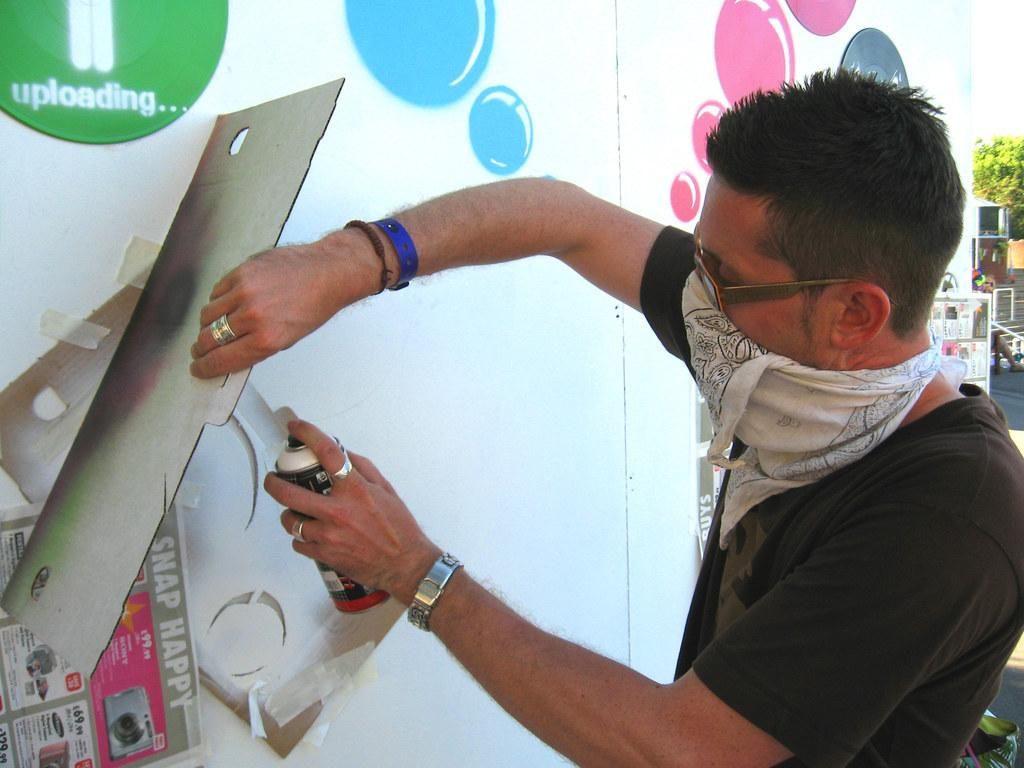Who is present in the image? There is a man in the image. What is the man wearing that is specific to his attire? The man is wearing goggles. What type of material can be seen in the image? There is cloth in the image. What is one object that can be seen in the image? There is a bottle in the image. What is another object that can be seen in the image? There is a board in the image. What is a decorative item that can be seen in the image? There is a poster in the image. What type of artwork is present in the image? There is a painting on a surface in the image. What can be seen in the background of the image? There is a tree, steps, and a person in the background of the image. What else can be seen in the background of the image? There are some objects in the background of the image. Reasoning: Let's let's think step by step in order to produce the conversation. We start by identifying the main subject in the image, which is the man. Then, we expand the conversation to include specific details about the man's attire, such as the goggles he is wearing. Next, we mention the various objects and items that are present in the image, including the cloth, bottle, board, poster, and painting. Finally, we describe the background of the image, which includes a tree, steps, a person, and some objects. Absurd Question/Answer: How does the pig contribute to the scene in the image? There is no pig present in the image. What type of loss is depicted in the image? There is no loss depicted in the image; it is a scene with a man, various objects, and a background. How does the person in the background stretch their arms in the image? There is no indication of anyone stretching their arms in the image. 